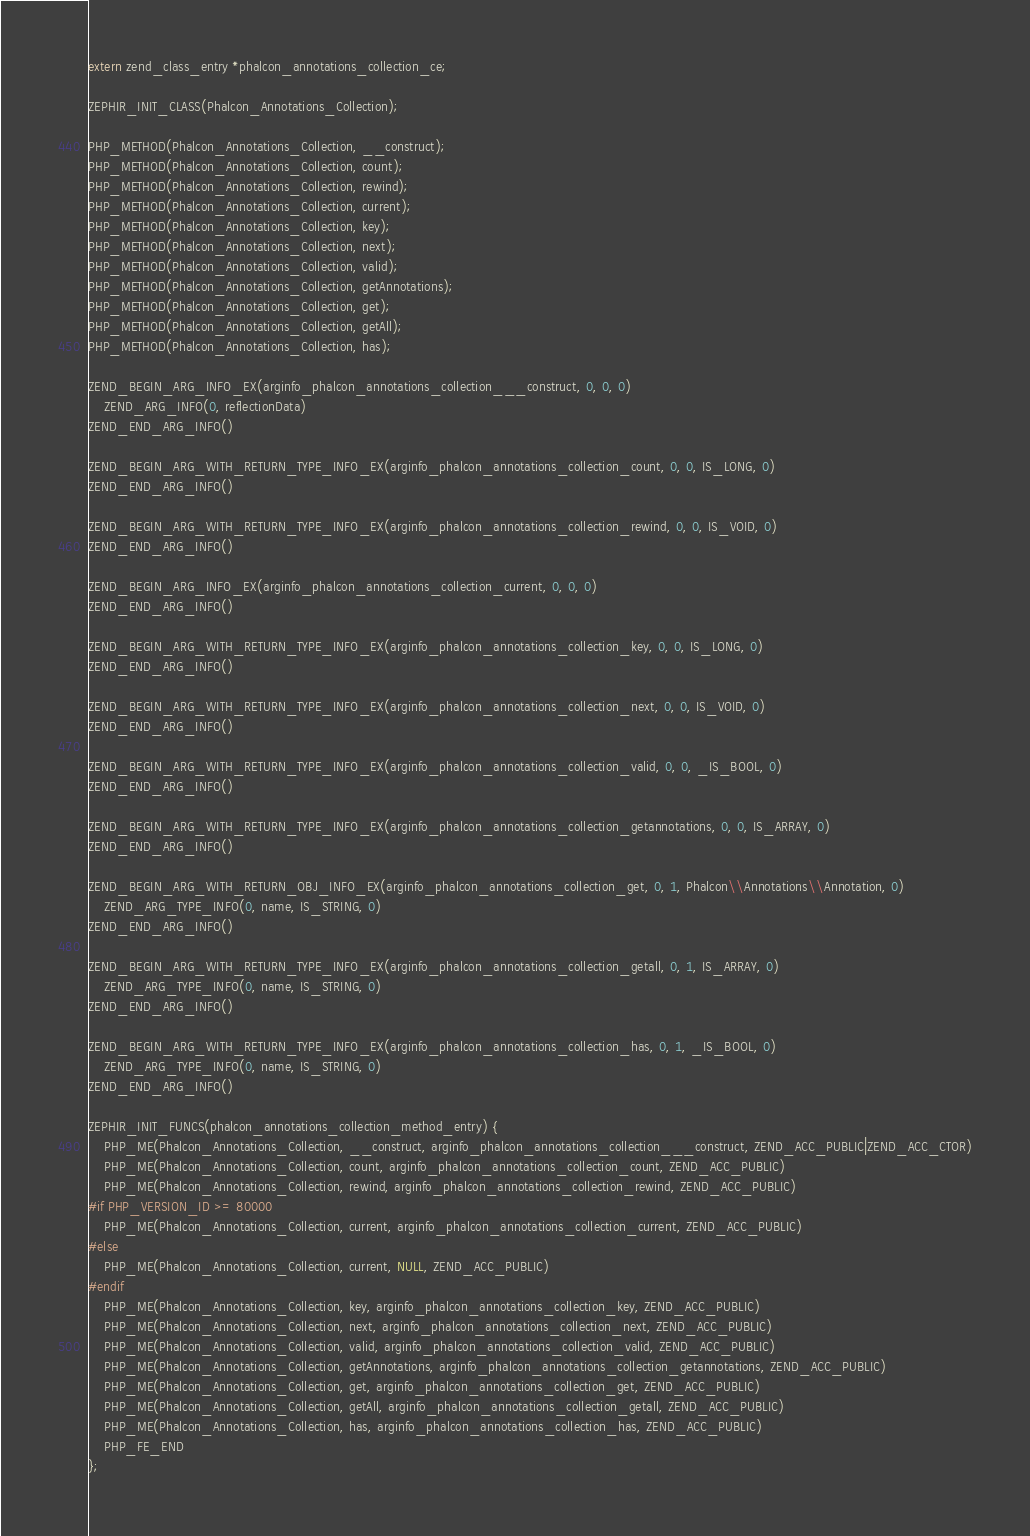<code> <loc_0><loc_0><loc_500><loc_500><_C_>
extern zend_class_entry *phalcon_annotations_collection_ce;

ZEPHIR_INIT_CLASS(Phalcon_Annotations_Collection);

PHP_METHOD(Phalcon_Annotations_Collection, __construct);
PHP_METHOD(Phalcon_Annotations_Collection, count);
PHP_METHOD(Phalcon_Annotations_Collection, rewind);
PHP_METHOD(Phalcon_Annotations_Collection, current);
PHP_METHOD(Phalcon_Annotations_Collection, key);
PHP_METHOD(Phalcon_Annotations_Collection, next);
PHP_METHOD(Phalcon_Annotations_Collection, valid);
PHP_METHOD(Phalcon_Annotations_Collection, getAnnotations);
PHP_METHOD(Phalcon_Annotations_Collection, get);
PHP_METHOD(Phalcon_Annotations_Collection, getAll);
PHP_METHOD(Phalcon_Annotations_Collection, has);

ZEND_BEGIN_ARG_INFO_EX(arginfo_phalcon_annotations_collection___construct, 0, 0, 0)
	ZEND_ARG_INFO(0, reflectionData)
ZEND_END_ARG_INFO()

ZEND_BEGIN_ARG_WITH_RETURN_TYPE_INFO_EX(arginfo_phalcon_annotations_collection_count, 0, 0, IS_LONG, 0)
ZEND_END_ARG_INFO()

ZEND_BEGIN_ARG_WITH_RETURN_TYPE_INFO_EX(arginfo_phalcon_annotations_collection_rewind, 0, 0, IS_VOID, 0)
ZEND_END_ARG_INFO()

ZEND_BEGIN_ARG_INFO_EX(arginfo_phalcon_annotations_collection_current, 0, 0, 0)
ZEND_END_ARG_INFO()

ZEND_BEGIN_ARG_WITH_RETURN_TYPE_INFO_EX(arginfo_phalcon_annotations_collection_key, 0, 0, IS_LONG, 0)
ZEND_END_ARG_INFO()

ZEND_BEGIN_ARG_WITH_RETURN_TYPE_INFO_EX(arginfo_phalcon_annotations_collection_next, 0, 0, IS_VOID, 0)
ZEND_END_ARG_INFO()

ZEND_BEGIN_ARG_WITH_RETURN_TYPE_INFO_EX(arginfo_phalcon_annotations_collection_valid, 0, 0, _IS_BOOL, 0)
ZEND_END_ARG_INFO()

ZEND_BEGIN_ARG_WITH_RETURN_TYPE_INFO_EX(arginfo_phalcon_annotations_collection_getannotations, 0, 0, IS_ARRAY, 0)
ZEND_END_ARG_INFO()

ZEND_BEGIN_ARG_WITH_RETURN_OBJ_INFO_EX(arginfo_phalcon_annotations_collection_get, 0, 1, Phalcon\\Annotations\\Annotation, 0)
	ZEND_ARG_TYPE_INFO(0, name, IS_STRING, 0)
ZEND_END_ARG_INFO()

ZEND_BEGIN_ARG_WITH_RETURN_TYPE_INFO_EX(arginfo_phalcon_annotations_collection_getall, 0, 1, IS_ARRAY, 0)
	ZEND_ARG_TYPE_INFO(0, name, IS_STRING, 0)
ZEND_END_ARG_INFO()

ZEND_BEGIN_ARG_WITH_RETURN_TYPE_INFO_EX(arginfo_phalcon_annotations_collection_has, 0, 1, _IS_BOOL, 0)
	ZEND_ARG_TYPE_INFO(0, name, IS_STRING, 0)
ZEND_END_ARG_INFO()

ZEPHIR_INIT_FUNCS(phalcon_annotations_collection_method_entry) {
	PHP_ME(Phalcon_Annotations_Collection, __construct, arginfo_phalcon_annotations_collection___construct, ZEND_ACC_PUBLIC|ZEND_ACC_CTOR)
	PHP_ME(Phalcon_Annotations_Collection, count, arginfo_phalcon_annotations_collection_count, ZEND_ACC_PUBLIC)
	PHP_ME(Phalcon_Annotations_Collection, rewind, arginfo_phalcon_annotations_collection_rewind, ZEND_ACC_PUBLIC)
#if PHP_VERSION_ID >= 80000
	PHP_ME(Phalcon_Annotations_Collection, current, arginfo_phalcon_annotations_collection_current, ZEND_ACC_PUBLIC)
#else
	PHP_ME(Phalcon_Annotations_Collection, current, NULL, ZEND_ACC_PUBLIC)
#endif
	PHP_ME(Phalcon_Annotations_Collection, key, arginfo_phalcon_annotations_collection_key, ZEND_ACC_PUBLIC)
	PHP_ME(Phalcon_Annotations_Collection, next, arginfo_phalcon_annotations_collection_next, ZEND_ACC_PUBLIC)
	PHP_ME(Phalcon_Annotations_Collection, valid, arginfo_phalcon_annotations_collection_valid, ZEND_ACC_PUBLIC)
	PHP_ME(Phalcon_Annotations_Collection, getAnnotations, arginfo_phalcon_annotations_collection_getannotations, ZEND_ACC_PUBLIC)
	PHP_ME(Phalcon_Annotations_Collection, get, arginfo_phalcon_annotations_collection_get, ZEND_ACC_PUBLIC)
	PHP_ME(Phalcon_Annotations_Collection, getAll, arginfo_phalcon_annotations_collection_getall, ZEND_ACC_PUBLIC)
	PHP_ME(Phalcon_Annotations_Collection, has, arginfo_phalcon_annotations_collection_has, ZEND_ACC_PUBLIC)
	PHP_FE_END
};
</code> 